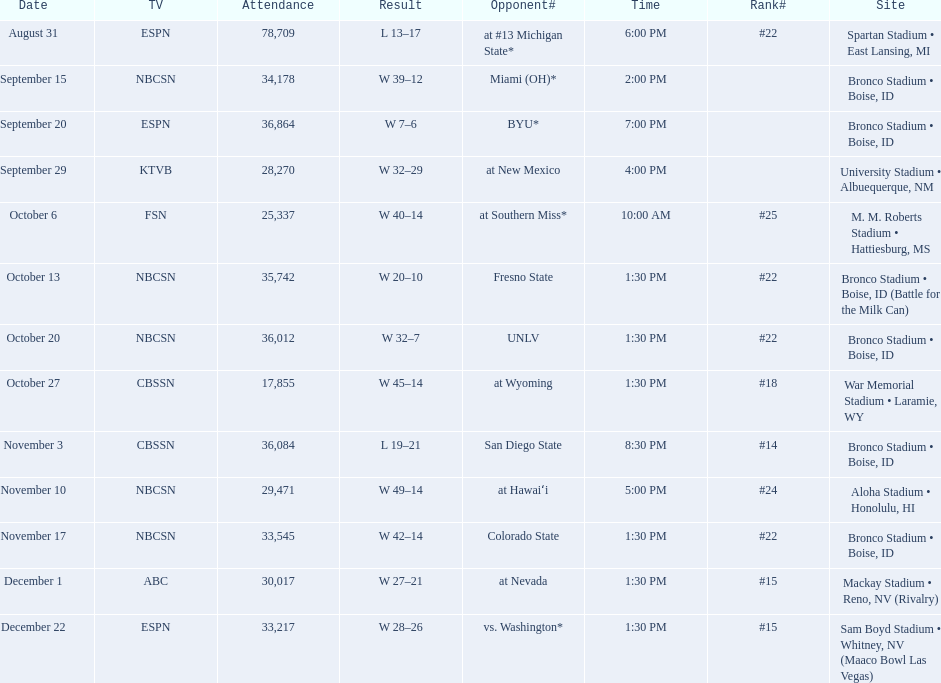What are the opponents to the  2012 boise state broncos football team? At #13 michigan state*, miami (oh)*, byu*, at new mexico, at southern miss*, fresno state, unlv, at wyoming, san diego state, at hawaiʻi, colorado state, at nevada, vs. washington*. Which is the highest ranked of the teams? San Diego State. 